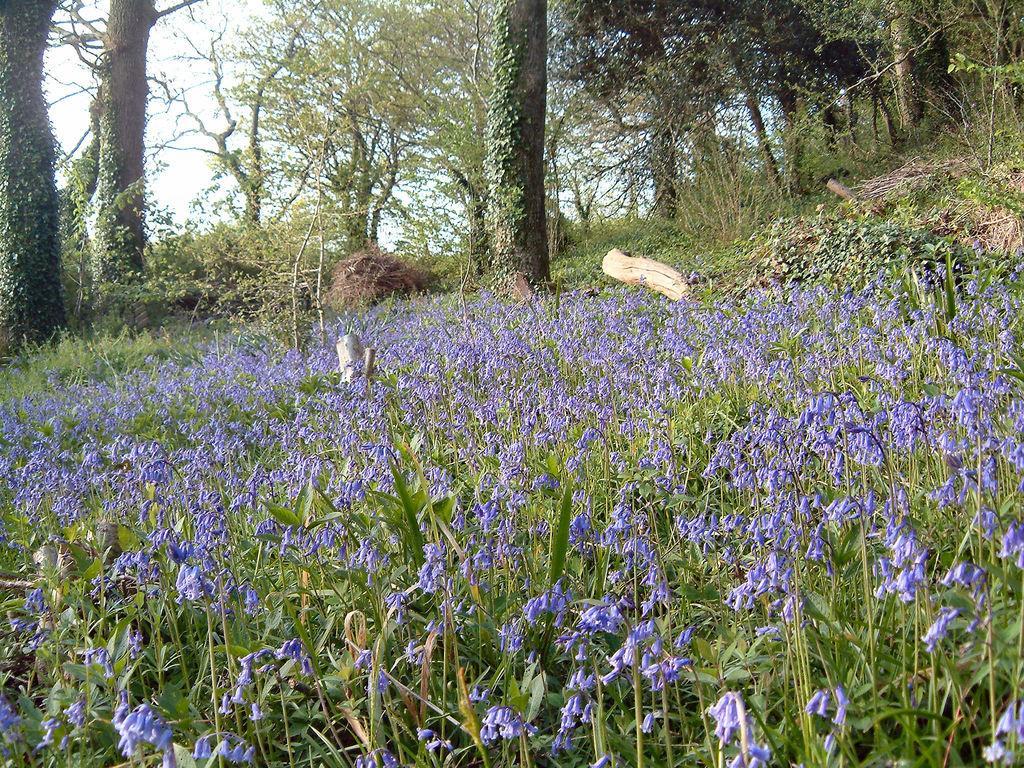Could you give a brief overview of what you see in this image? In this image we can see a group of plants with flowers. We can also see the bark of the trees, some dried plants, a group of trees and the sky which looks cloudy. 